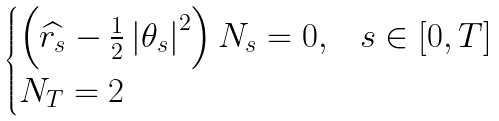Convert formula to latex. <formula><loc_0><loc_0><loc_500><loc_500>\begin{cases} \left ( \widehat { r _ { s } } - \frac { 1 } { 2 } \left | \theta _ { s } \right | ^ { 2 } \right ) N _ { s } = 0 , & s \in \left [ 0 , T \right ] \\ N _ { T } = 2 \end{cases}</formula> 